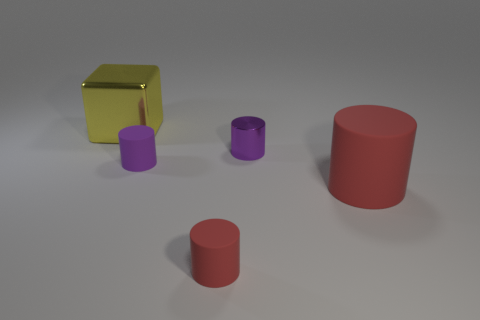What number of other things are the same size as the purple rubber thing?
Make the answer very short. 2. Are there an equal number of big cylinders left of the purple metal object and small green rubber objects?
Keep it short and to the point. Yes. Does the small cylinder on the right side of the small red rubber cylinder have the same color as the matte thing left of the tiny red cylinder?
Offer a terse response. Yes. There is a object that is both on the right side of the tiny red cylinder and to the left of the big cylinder; what is it made of?
Your answer should be very brief. Metal. The big matte cylinder has what color?
Offer a very short reply. Red. How many other objects are there of the same shape as the big red rubber object?
Give a very brief answer. 3. Are there the same number of tiny purple metal objects behind the big red matte thing and yellow blocks that are behind the yellow thing?
Offer a very short reply. No. What is the material of the big yellow block?
Offer a very short reply. Metal. There is a thing that is behind the small purple metal object; what is its material?
Your response must be concise. Metal. Is there any other thing that is made of the same material as the block?
Provide a short and direct response. Yes. 